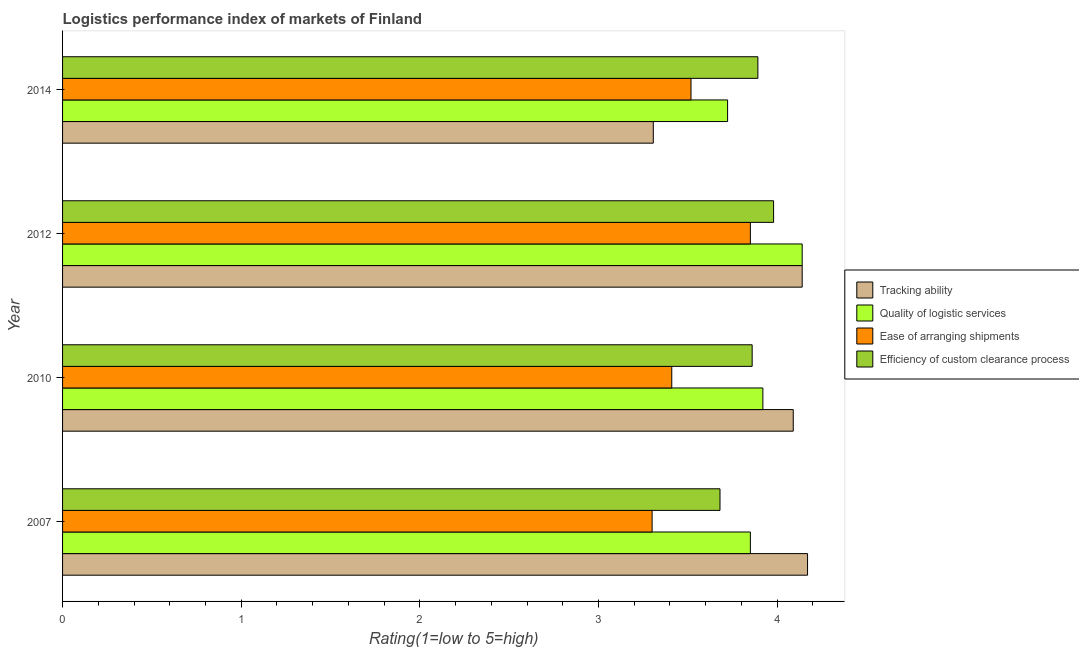How many different coloured bars are there?
Provide a short and direct response. 4. How many groups of bars are there?
Ensure brevity in your answer.  4. How many bars are there on the 4th tick from the bottom?
Offer a terse response. 4. What is the label of the 4th group of bars from the top?
Make the answer very short. 2007. In how many cases, is the number of bars for a given year not equal to the number of legend labels?
Keep it short and to the point. 0. What is the lpi rating of efficiency of custom clearance process in 2012?
Offer a very short reply. 3.98. Across all years, what is the maximum lpi rating of tracking ability?
Make the answer very short. 4.17. Across all years, what is the minimum lpi rating of quality of logistic services?
Provide a short and direct response. 3.72. In which year was the lpi rating of ease of arranging shipments maximum?
Ensure brevity in your answer.  2012. What is the total lpi rating of tracking ability in the graph?
Offer a terse response. 15.71. What is the difference between the lpi rating of efficiency of custom clearance process in 2010 and that in 2014?
Offer a terse response. -0.03. What is the difference between the lpi rating of efficiency of custom clearance process in 2014 and the lpi rating of ease of arranging shipments in 2007?
Your answer should be compact. 0.59. What is the average lpi rating of quality of logistic services per year?
Your answer should be compact. 3.91. In the year 2012, what is the difference between the lpi rating of efficiency of custom clearance process and lpi rating of ease of arranging shipments?
Keep it short and to the point. 0.13. In how many years, is the lpi rating of tracking ability greater than 0.6000000000000001 ?
Ensure brevity in your answer.  4. What is the ratio of the lpi rating of quality of logistic services in 2007 to that in 2010?
Your response must be concise. 0.98. Is the lpi rating of efficiency of custom clearance process in 2007 less than that in 2012?
Provide a short and direct response. Yes. What is the difference between the highest and the lowest lpi rating of ease of arranging shipments?
Give a very brief answer. 0.55. Is the sum of the lpi rating of ease of arranging shipments in 2007 and 2010 greater than the maximum lpi rating of tracking ability across all years?
Ensure brevity in your answer.  Yes. Is it the case that in every year, the sum of the lpi rating of tracking ability and lpi rating of ease of arranging shipments is greater than the sum of lpi rating of quality of logistic services and lpi rating of efficiency of custom clearance process?
Offer a very short reply. No. What does the 4th bar from the top in 2007 represents?
Give a very brief answer. Tracking ability. What does the 3rd bar from the bottom in 2007 represents?
Offer a terse response. Ease of arranging shipments. Are all the bars in the graph horizontal?
Provide a short and direct response. Yes. Does the graph contain any zero values?
Your answer should be compact. No. How many legend labels are there?
Your answer should be very brief. 4. How are the legend labels stacked?
Your response must be concise. Vertical. What is the title of the graph?
Provide a succinct answer. Logistics performance index of markets of Finland. What is the label or title of the X-axis?
Keep it short and to the point. Rating(1=low to 5=high). What is the Rating(1=low to 5=high) in Tracking ability in 2007?
Ensure brevity in your answer.  4.17. What is the Rating(1=low to 5=high) of Quality of logistic services in 2007?
Your answer should be very brief. 3.85. What is the Rating(1=low to 5=high) in Efficiency of custom clearance process in 2007?
Make the answer very short. 3.68. What is the Rating(1=low to 5=high) in Tracking ability in 2010?
Ensure brevity in your answer.  4.09. What is the Rating(1=low to 5=high) in Quality of logistic services in 2010?
Your response must be concise. 3.92. What is the Rating(1=low to 5=high) in Ease of arranging shipments in 2010?
Keep it short and to the point. 3.41. What is the Rating(1=low to 5=high) of Efficiency of custom clearance process in 2010?
Your answer should be very brief. 3.86. What is the Rating(1=low to 5=high) in Tracking ability in 2012?
Your answer should be compact. 4.14. What is the Rating(1=low to 5=high) of Quality of logistic services in 2012?
Keep it short and to the point. 4.14. What is the Rating(1=low to 5=high) in Ease of arranging shipments in 2012?
Your answer should be compact. 3.85. What is the Rating(1=low to 5=high) in Efficiency of custom clearance process in 2012?
Give a very brief answer. 3.98. What is the Rating(1=low to 5=high) of Tracking ability in 2014?
Give a very brief answer. 3.31. What is the Rating(1=low to 5=high) in Quality of logistic services in 2014?
Offer a terse response. 3.72. What is the Rating(1=low to 5=high) in Ease of arranging shipments in 2014?
Your response must be concise. 3.52. What is the Rating(1=low to 5=high) of Efficiency of custom clearance process in 2014?
Your answer should be very brief. 3.89. Across all years, what is the maximum Rating(1=low to 5=high) of Tracking ability?
Offer a very short reply. 4.17. Across all years, what is the maximum Rating(1=low to 5=high) of Quality of logistic services?
Your response must be concise. 4.14. Across all years, what is the maximum Rating(1=low to 5=high) of Ease of arranging shipments?
Ensure brevity in your answer.  3.85. Across all years, what is the maximum Rating(1=low to 5=high) of Efficiency of custom clearance process?
Your answer should be compact. 3.98. Across all years, what is the minimum Rating(1=low to 5=high) in Tracking ability?
Keep it short and to the point. 3.31. Across all years, what is the minimum Rating(1=low to 5=high) of Quality of logistic services?
Provide a short and direct response. 3.72. Across all years, what is the minimum Rating(1=low to 5=high) in Efficiency of custom clearance process?
Your answer should be very brief. 3.68. What is the total Rating(1=low to 5=high) of Tracking ability in the graph?
Your answer should be very brief. 15.71. What is the total Rating(1=low to 5=high) in Quality of logistic services in the graph?
Make the answer very short. 15.63. What is the total Rating(1=low to 5=high) in Ease of arranging shipments in the graph?
Offer a very short reply. 14.08. What is the total Rating(1=low to 5=high) of Efficiency of custom clearance process in the graph?
Ensure brevity in your answer.  15.41. What is the difference between the Rating(1=low to 5=high) of Quality of logistic services in 2007 and that in 2010?
Your response must be concise. -0.07. What is the difference between the Rating(1=low to 5=high) of Ease of arranging shipments in 2007 and that in 2010?
Your answer should be very brief. -0.11. What is the difference between the Rating(1=low to 5=high) in Efficiency of custom clearance process in 2007 and that in 2010?
Offer a terse response. -0.18. What is the difference between the Rating(1=low to 5=high) in Tracking ability in 2007 and that in 2012?
Your answer should be very brief. 0.03. What is the difference between the Rating(1=low to 5=high) of Quality of logistic services in 2007 and that in 2012?
Provide a succinct answer. -0.29. What is the difference between the Rating(1=low to 5=high) in Ease of arranging shipments in 2007 and that in 2012?
Offer a terse response. -0.55. What is the difference between the Rating(1=low to 5=high) in Efficiency of custom clearance process in 2007 and that in 2012?
Offer a terse response. -0.3. What is the difference between the Rating(1=low to 5=high) in Tracking ability in 2007 and that in 2014?
Offer a terse response. 0.86. What is the difference between the Rating(1=low to 5=high) in Quality of logistic services in 2007 and that in 2014?
Ensure brevity in your answer.  0.13. What is the difference between the Rating(1=low to 5=high) of Ease of arranging shipments in 2007 and that in 2014?
Keep it short and to the point. -0.22. What is the difference between the Rating(1=low to 5=high) of Efficiency of custom clearance process in 2007 and that in 2014?
Make the answer very short. -0.21. What is the difference between the Rating(1=low to 5=high) in Tracking ability in 2010 and that in 2012?
Your answer should be compact. -0.05. What is the difference between the Rating(1=low to 5=high) of Quality of logistic services in 2010 and that in 2012?
Ensure brevity in your answer.  -0.22. What is the difference between the Rating(1=low to 5=high) in Ease of arranging shipments in 2010 and that in 2012?
Your answer should be compact. -0.44. What is the difference between the Rating(1=low to 5=high) of Efficiency of custom clearance process in 2010 and that in 2012?
Your response must be concise. -0.12. What is the difference between the Rating(1=low to 5=high) of Tracking ability in 2010 and that in 2014?
Offer a very short reply. 0.78. What is the difference between the Rating(1=low to 5=high) of Quality of logistic services in 2010 and that in 2014?
Give a very brief answer. 0.2. What is the difference between the Rating(1=low to 5=high) in Ease of arranging shipments in 2010 and that in 2014?
Provide a succinct answer. -0.11. What is the difference between the Rating(1=low to 5=high) of Efficiency of custom clearance process in 2010 and that in 2014?
Offer a terse response. -0.03. What is the difference between the Rating(1=low to 5=high) of Tracking ability in 2012 and that in 2014?
Make the answer very short. 0.83. What is the difference between the Rating(1=low to 5=high) in Quality of logistic services in 2012 and that in 2014?
Give a very brief answer. 0.42. What is the difference between the Rating(1=low to 5=high) in Ease of arranging shipments in 2012 and that in 2014?
Ensure brevity in your answer.  0.33. What is the difference between the Rating(1=low to 5=high) in Efficiency of custom clearance process in 2012 and that in 2014?
Provide a short and direct response. 0.09. What is the difference between the Rating(1=low to 5=high) in Tracking ability in 2007 and the Rating(1=low to 5=high) in Ease of arranging shipments in 2010?
Offer a terse response. 0.76. What is the difference between the Rating(1=low to 5=high) in Tracking ability in 2007 and the Rating(1=low to 5=high) in Efficiency of custom clearance process in 2010?
Make the answer very short. 0.31. What is the difference between the Rating(1=low to 5=high) in Quality of logistic services in 2007 and the Rating(1=low to 5=high) in Ease of arranging shipments in 2010?
Provide a succinct answer. 0.44. What is the difference between the Rating(1=low to 5=high) of Quality of logistic services in 2007 and the Rating(1=low to 5=high) of Efficiency of custom clearance process in 2010?
Provide a succinct answer. -0.01. What is the difference between the Rating(1=low to 5=high) in Ease of arranging shipments in 2007 and the Rating(1=low to 5=high) in Efficiency of custom clearance process in 2010?
Your response must be concise. -0.56. What is the difference between the Rating(1=low to 5=high) in Tracking ability in 2007 and the Rating(1=low to 5=high) in Quality of logistic services in 2012?
Your answer should be compact. 0.03. What is the difference between the Rating(1=low to 5=high) in Tracking ability in 2007 and the Rating(1=low to 5=high) in Ease of arranging shipments in 2012?
Offer a terse response. 0.32. What is the difference between the Rating(1=low to 5=high) in Tracking ability in 2007 and the Rating(1=low to 5=high) in Efficiency of custom clearance process in 2012?
Offer a terse response. 0.19. What is the difference between the Rating(1=low to 5=high) of Quality of logistic services in 2007 and the Rating(1=low to 5=high) of Efficiency of custom clearance process in 2012?
Your answer should be compact. -0.13. What is the difference between the Rating(1=low to 5=high) of Ease of arranging shipments in 2007 and the Rating(1=low to 5=high) of Efficiency of custom clearance process in 2012?
Provide a succinct answer. -0.68. What is the difference between the Rating(1=low to 5=high) in Tracking ability in 2007 and the Rating(1=low to 5=high) in Quality of logistic services in 2014?
Keep it short and to the point. 0.45. What is the difference between the Rating(1=low to 5=high) in Tracking ability in 2007 and the Rating(1=low to 5=high) in Ease of arranging shipments in 2014?
Provide a short and direct response. 0.65. What is the difference between the Rating(1=low to 5=high) in Tracking ability in 2007 and the Rating(1=low to 5=high) in Efficiency of custom clearance process in 2014?
Provide a short and direct response. 0.28. What is the difference between the Rating(1=low to 5=high) of Quality of logistic services in 2007 and the Rating(1=low to 5=high) of Ease of arranging shipments in 2014?
Offer a very short reply. 0.33. What is the difference between the Rating(1=low to 5=high) in Quality of logistic services in 2007 and the Rating(1=low to 5=high) in Efficiency of custom clearance process in 2014?
Give a very brief answer. -0.04. What is the difference between the Rating(1=low to 5=high) of Ease of arranging shipments in 2007 and the Rating(1=low to 5=high) of Efficiency of custom clearance process in 2014?
Your answer should be very brief. -0.59. What is the difference between the Rating(1=low to 5=high) of Tracking ability in 2010 and the Rating(1=low to 5=high) of Ease of arranging shipments in 2012?
Provide a short and direct response. 0.24. What is the difference between the Rating(1=low to 5=high) of Tracking ability in 2010 and the Rating(1=low to 5=high) of Efficiency of custom clearance process in 2012?
Your answer should be very brief. 0.11. What is the difference between the Rating(1=low to 5=high) in Quality of logistic services in 2010 and the Rating(1=low to 5=high) in Ease of arranging shipments in 2012?
Make the answer very short. 0.07. What is the difference between the Rating(1=low to 5=high) in Quality of logistic services in 2010 and the Rating(1=low to 5=high) in Efficiency of custom clearance process in 2012?
Offer a very short reply. -0.06. What is the difference between the Rating(1=low to 5=high) in Ease of arranging shipments in 2010 and the Rating(1=low to 5=high) in Efficiency of custom clearance process in 2012?
Make the answer very short. -0.57. What is the difference between the Rating(1=low to 5=high) in Tracking ability in 2010 and the Rating(1=low to 5=high) in Quality of logistic services in 2014?
Give a very brief answer. 0.37. What is the difference between the Rating(1=low to 5=high) of Tracking ability in 2010 and the Rating(1=low to 5=high) of Ease of arranging shipments in 2014?
Your answer should be very brief. 0.57. What is the difference between the Rating(1=low to 5=high) in Tracking ability in 2010 and the Rating(1=low to 5=high) in Efficiency of custom clearance process in 2014?
Make the answer very short. 0.2. What is the difference between the Rating(1=low to 5=high) in Quality of logistic services in 2010 and the Rating(1=low to 5=high) in Ease of arranging shipments in 2014?
Keep it short and to the point. 0.4. What is the difference between the Rating(1=low to 5=high) of Quality of logistic services in 2010 and the Rating(1=low to 5=high) of Efficiency of custom clearance process in 2014?
Make the answer very short. 0.03. What is the difference between the Rating(1=low to 5=high) in Ease of arranging shipments in 2010 and the Rating(1=low to 5=high) in Efficiency of custom clearance process in 2014?
Your answer should be compact. -0.48. What is the difference between the Rating(1=low to 5=high) in Tracking ability in 2012 and the Rating(1=low to 5=high) in Quality of logistic services in 2014?
Make the answer very short. 0.42. What is the difference between the Rating(1=low to 5=high) in Tracking ability in 2012 and the Rating(1=low to 5=high) in Ease of arranging shipments in 2014?
Your answer should be very brief. 0.62. What is the difference between the Rating(1=low to 5=high) in Tracking ability in 2012 and the Rating(1=low to 5=high) in Efficiency of custom clearance process in 2014?
Your answer should be compact. 0.25. What is the difference between the Rating(1=low to 5=high) of Quality of logistic services in 2012 and the Rating(1=low to 5=high) of Ease of arranging shipments in 2014?
Offer a terse response. 0.62. What is the difference between the Rating(1=low to 5=high) of Quality of logistic services in 2012 and the Rating(1=low to 5=high) of Efficiency of custom clearance process in 2014?
Your response must be concise. 0.25. What is the difference between the Rating(1=low to 5=high) in Ease of arranging shipments in 2012 and the Rating(1=low to 5=high) in Efficiency of custom clearance process in 2014?
Give a very brief answer. -0.04. What is the average Rating(1=low to 5=high) in Tracking ability per year?
Provide a succinct answer. 3.93. What is the average Rating(1=low to 5=high) of Quality of logistic services per year?
Keep it short and to the point. 3.91. What is the average Rating(1=low to 5=high) in Ease of arranging shipments per year?
Provide a succinct answer. 3.52. What is the average Rating(1=low to 5=high) in Efficiency of custom clearance process per year?
Keep it short and to the point. 3.85. In the year 2007, what is the difference between the Rating(1=low to 5=high) in Tracking ability and Rating(1=low to 5=high) in Quality of logistic services?
Provide a short and direct response. 0.32. In the year 2007, what is the difference between the Rating(1=low to 5=high) in Tracking ability and Rating(1=low to 5=high) in Ease of arranging shipments?
Provide a succinct answer. 0.87. In the year 2007, what is the difference between the Rating(1=low to 5=high) of Tracking ability and Rating(1=low to 5=high) of Efficiency of custom clearance process?
Keep it short and to the point. 0.49. In the year 2007, what is the difference between the Rating(1=low to 5=high) of Quality of logistic services and Rating(1=low to 5=high) of Ease of arranging shipments?
Provide a succinct answer. 0.55. In the year 2007, what is the difference between the Rating(1=low to 5=high) in Quality of logistic services and Rating(1=low to 5=high) in Efficiency of custom clearance process?
Provide a succinct answer. 0.17. In the year 2007, what is the difference between the Rating(1=low to 5=high) in Ease of arranging shipments and Rating(1=low to 5=high) in Efficiency of custom clearance process?
Make the answer very short. -0.38. In the year 2010, what is the difference between the Rating(1=low to 5=high) in Tracking ability and Rating(1=low to 5=high) in Quality of logistic services?
Your response must be concise. 0.17. In the year 2010, what is the difference between the Rating(1=low to 5=high) in Tracking ability and Rating(1=low to 5=high) in Ease of arranging shipments?
Your response must be concise. 0.68. In the year 2010, what is the difference between the Rating(1=low to 5=high) of Tracking ability and Rating(1=low to 5=high) of Efficiency of custom clearance process?
Offer a terse response. 0.23. In the year 2010, what is the difference between the Rating(1=low to 5=high) in Quality of logistic services and Rating(1=low to 5=high) in Ease of arranging shipments?
Your answer should be very brief. 0.51. In the year 2010, what is the difference between the Rating(1=low to 5=high) in Quality of logistic services and Rating(1=low to 5=high) in Efficiency of custom clearance process?
Make the answer very short. 0.06. In the year 2010, what is the difference between the Rating(1=low to 5=high) in Ease of arranging shipments and Rating(1=low to 5=high) in Efficiency of custom clearance process?
Provide a succinct answer. -0.45. In the year 2012, what is the difference between the Rating(1=low to 5=high) of Tracking ability and Rating(1=low to 5=high) of Quality of logistic services?
Ensure brevity in your answer.  0. In the year 2012, what is the difference between the Rating(1=low to 5=high) in Tracking ability and Rating(1=low to 5=high) in Ease of arranging shipments?
Give a very brief answer. 0.29. In the year 2012, what is the difference between the Rating(1=low to 5=high) of Tracking ability and Rating(1=low to 5=high) of Efficiency of custom clearance process?
Your answer should be compact. 0.16. In the year 2012, what is the difference between the Rating(1=low to 5=high) in Quality of logistic services and Rating(1=low to 5=high) in Ease of arranging shipments?
Give a very brief answer. 0.29. In the year 2012, what is the difference between the Rating(1=low to 5=high) in Quality of logistic services and Rating(1=low to 5=high) in Efficiency of custom clearance process?
Offer a terse response. 0.16. In the year 2012, what is the difference between the Rating(1=low to 5=high) of Ease of arranging shipments and Rating(1=low to 5=high) of Efficiency of custom clearance process?
Ensure brevity in your answer.  -0.13. In the year 2014, what is the difference between the Rating(1=low to 5=high) of Tracking ability and Rating(1=low to 5=high) of Quality of logistic services?
Your response must be concise. -0.42. In the year 2014, what is the difference between the Rating(1=low to 5=high) of Tracking ability and Rating(1=low to 5=high) of Ease of arranging shipments?
Provide a short and direct response. -0.21. In the year 2014, what is the difference between the Rating(1=low to 5=high) of Tracking ability and Rating(1=low to 5=high) of Efficiency of custom clearance process?
Provide a succinct answer. -0.59. In the year 2014, what is the difference between the Rating(1=low to 5=high) of Quality of logistic services and Rating(1=low to 5=high) of Ease of arranging shipments?
Provide a short and direct response. 0.2. In the year 2014, what is the difference between the Rating(1=low to 5=high) of Quality of logistic services and Rating(1=low to 5=high) of Efficiency of custom clearance process?
Your response must be concise. -0.17. In the year 2014, what is the difference between the Rating(1=low to 5=high) in Ease of arranging shipments and Rating(1=low to 5=high) in Efficiency of custom clearance process?
Provide a short and direct response. -0.37. What is the ratio of the Rating(1=low to 5=high) in Tracking ability in 2007 to that in 2010?
Offer a very short reply. 1.02. What is the ratio of the Rating(1=low to 5=high) of Quality of logistic services in 2007 to that in 2010?
Offer a terse response. 0.98. What is the ratio of the Rating(1=low to 5=high) of Efficiency of custom clearance process in 2007 to that in 2010?
Provide a succinct answer. 0.95. What is the ratio of the Rating(1=low to 5=high) of Tracking ability in 2007 to that in 2012?
Give a very brief answer. 1.01. What is the ratio of the Rating(1=low to 5=high) in Quality of logistic services in 2007 to that in 2012?
Offer a very short reply. 0.93. What is the ratio of the Rating(1=low to 5=high) in Ease of arranging shipments in 2007 to that in 2012?
Give a very brief answer. 0.86. What is the ratio of the Rating(1=low to 5=high) of Efficiency of custom clearance process in 2007 to that in 2012?
Your response must be concise. 0.92. What is the ratio of the Rating(1=low to 5=high) of Tracking ability in 2007 to that in 2014?
Provide a succinct answer. 1.26. What is the ratio of the Rating(1=low to 5=high) of Quality of logistic services in 2007 to that in 2014?
Give a very brief answer. 1.03. What is the ratio of the Rating(1=low to 5=high) in Ease of arranging shipments in 2007 to that in 2014?
Ensure brevity in your answer.  0.94. What is the ratio of the Rating(1=low to 5=high) in Efficiency of custom clearance process in 2007 to that in 2014?
Make the answer very short. 0.95. What is the ratio of the Rating(1=low to 5=high) of Tracking ability in 2010 to that in 2012?
Your response must be concise. 0.99. What is the ratio of the Rating(1=low to 5=high) in Quality of logistic services in 2010 to that in 2012?
Your response must be concise. 0.95. What is the ratio of the Rating(1=low to 5=high) in Ease of arranging shipments in 2010 to that in 2012?
Your answer should be very brief. 0.89. What is the ratio of the Rating(1=low to 5=high) of Efficiency of custom clearance process in 2010 to that in 2012?
Give a very brief answer. 0.97. What is the ratio of the Rating(1=low to 5=high) in Tracking ability in 2010 to that in 2014?
Keep it short and to the point. 1.24. What is the ratio of the Rating(1=low to 5=high) of Quality of logistic services in 2010 to that in 2014?
Your answer should be compact. 1.05. What is the ratio of the Rating(1=low to 5=high) in Ease of arranging shipments in 2010 to that in 2014?
Provide a succinct answer. 0.97. What is the ratio of the Rating(1=low to 5=high) of Tracking ability in 2012 to that in 2014?
Your answer should be very brief. 1.25. What is the ratio of the Rating(1=low to 5=high) of Quality of logistic services in 2012 to that in 2014?
Your response must be concise. 1.11. What is the ratio of the Rating(1=low to 5=high) of Ease of arranging shipments in 2012 to that in 2014?
Provide a short and direct response. 1.09. What is the ratio of the Rating(1=low to 5=high) of Efficiency of custom clearance process in 2012 to that in 2014?
Make the answer very short. 1.02. What is the difference between the highest and the second highest Rating(1=low to 5=high) of Tracking ability?
Provide a succinct answer. 0.03. What is the difference between the highest and the second highest Rating(1=low to 5=high) of Quality of logistic services?
Your response must be concise. 0.22. What is the difference between the highest and the second highest Rating(1=low to 5=high) in Ease of arranging shipments?
Ensure brevity in your answer.  0.33. What is the difference between the highest and the second highest Rating(1=low to 5=high) in Efficiency of custom clearance process?
Ensure brevity in your answer.  0.09. What is the difference between the highest and the lowest Rating(1=low to 5=high) in Tracking ability?
Provide a short and direct response. 0.86. What is the difference between the highest and the lowest Rating(1=low to 5=high) of Quality of logistic services?
Offer a terse response. 0.42. What is the difference between the highest and the lowest Rating(1=low to 5=high) of Ease of arranging shipments?
Provide a succinct answer. 0.55. What is the difference between the highest and the lowest Rating(1=low to 5=high) in Efficiency of custom clearance process?
Offer a terse response. 0.3. 